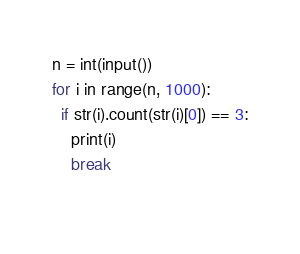Convert code to text. <code><loc_0><loc_0><loc_500><loc_500><_Python_>n = int(input())
for i in range(n, 1000):
  if str(i).count(str(i)[0]) == 3:
    print(i)
    break
  </code> 